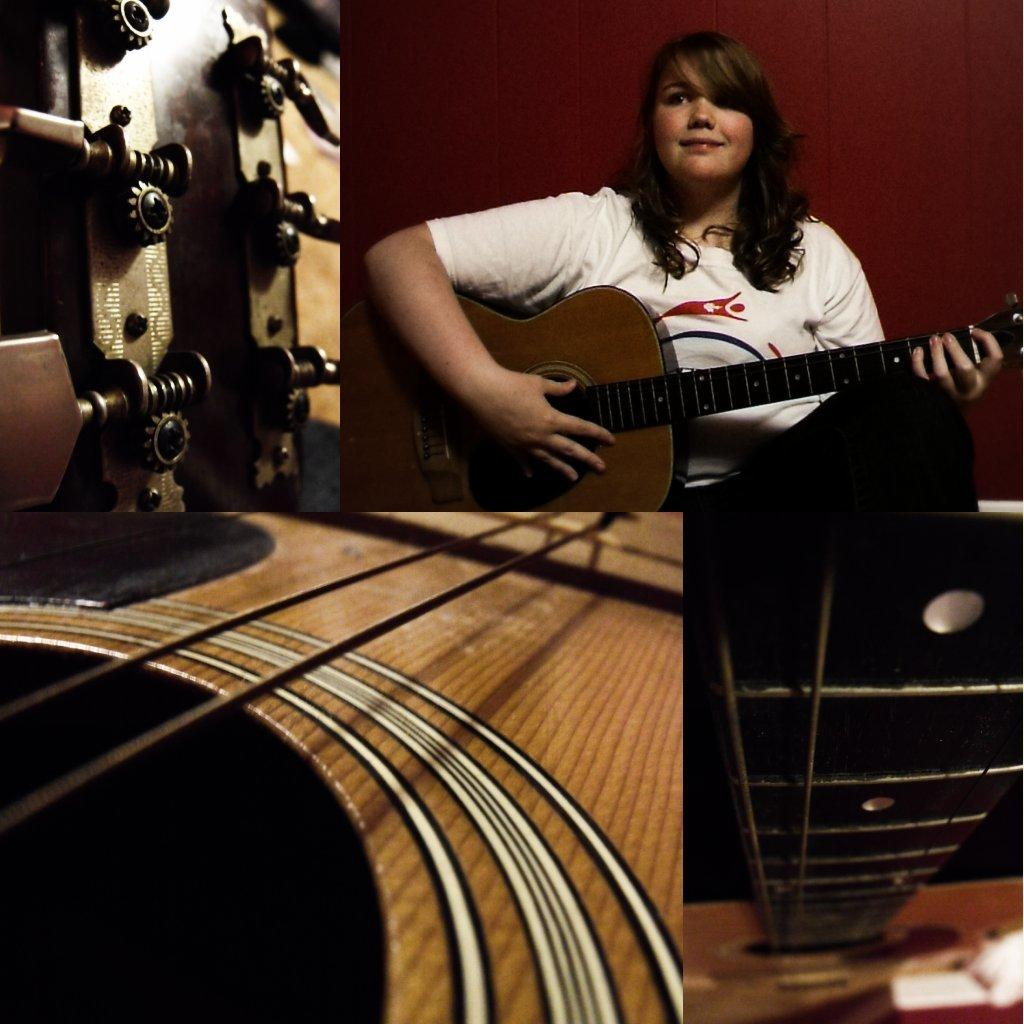Who is the main subject in the collage? There is the lady playing a guitar. What is the lady doing in the collage? The lady is playing a guitar and smiling. What is the lady wearing in the collage? The lady is wearing a white t-shirt. What other elements are present in the collage? There are parts of a guitar in the other three images of the collage. What type of soap is the lady using to clean her guitar in the image? There is no soap present in the image, and the lady is not cleaning her guitar; she is playing it. 